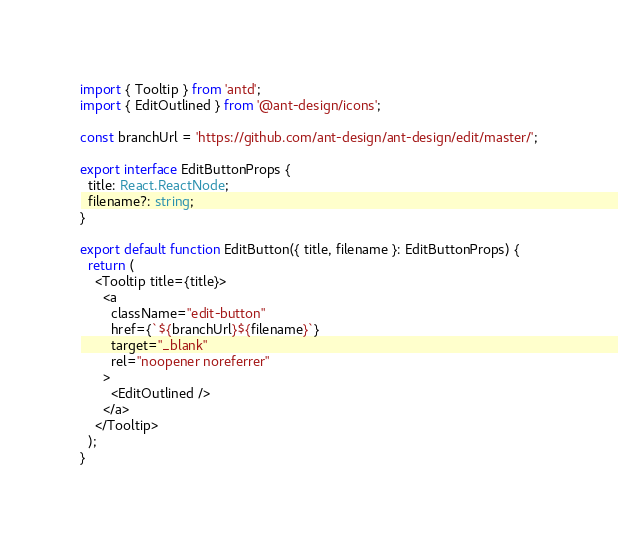<code> <loc_0><loc_0><loc_500><loc_500><_TypeScript_>import { Tooltip } from 'antd';
import { EditOutlined } from '@ant-design/icons';

const branchUrl = 'https://github.com/ant-design/ant-design/edit/master/';

export interface EditButtonProps {
  title: React.ReactNode;
  filename?: string;
}

export default function EditButton({ title, filename }: EditButtonProps) {
  return (
    <Tooltip title={title}>
      <a
        className="edit-button"
        href={`${branchUrl}${filename}`}
        target="_blank"
        rel="noopener noreferrer"
      >
        <EditOutlined />
      </a>
    </Tooltip>
  );
}
</code> 